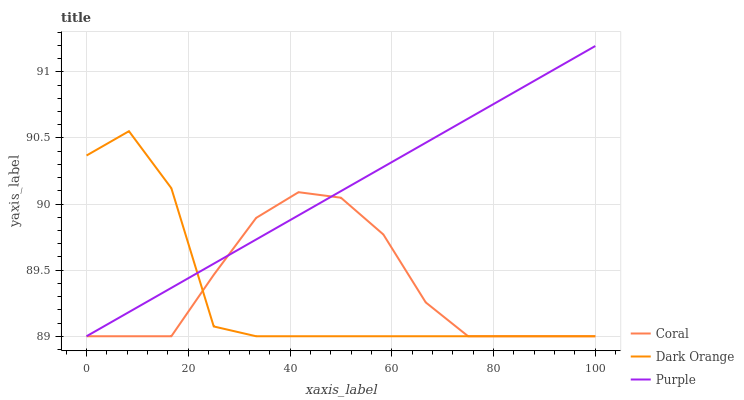Does Dark Orange have the minimum area under the curve?
Answer yes or no. Yes. Does Purple have the maximum area under the curve?
Answer yes or no. Yes. Does Coral have the minimum area under the curve?
Answer yes or no. No. Does Coral have the maximum area under the curve?
Answer yes or no. No. Is Purple the smoothest?
Answer yes or no. Yes. Is Dark Orange the roughest?
Answer yes or no. Yes. Is Coral the smoothest?
Answer yes or no. No. Is Coral the roughest?
Answer yes or no. No. Does Purple have the lowest value?
Answer yes or no. Yes. Does Purple have the highest value?
Answer yes or no. Yes. Does Dark Orange have the highest value?
Answer yes or no. No. Does Coral intersect Dark Orange?
Answer yes or no. Yes. Is Coral less than Dark Orange?
Answer yes or no. No. Is Coral greater than Dark Orange?
Answer yes or no. No. 